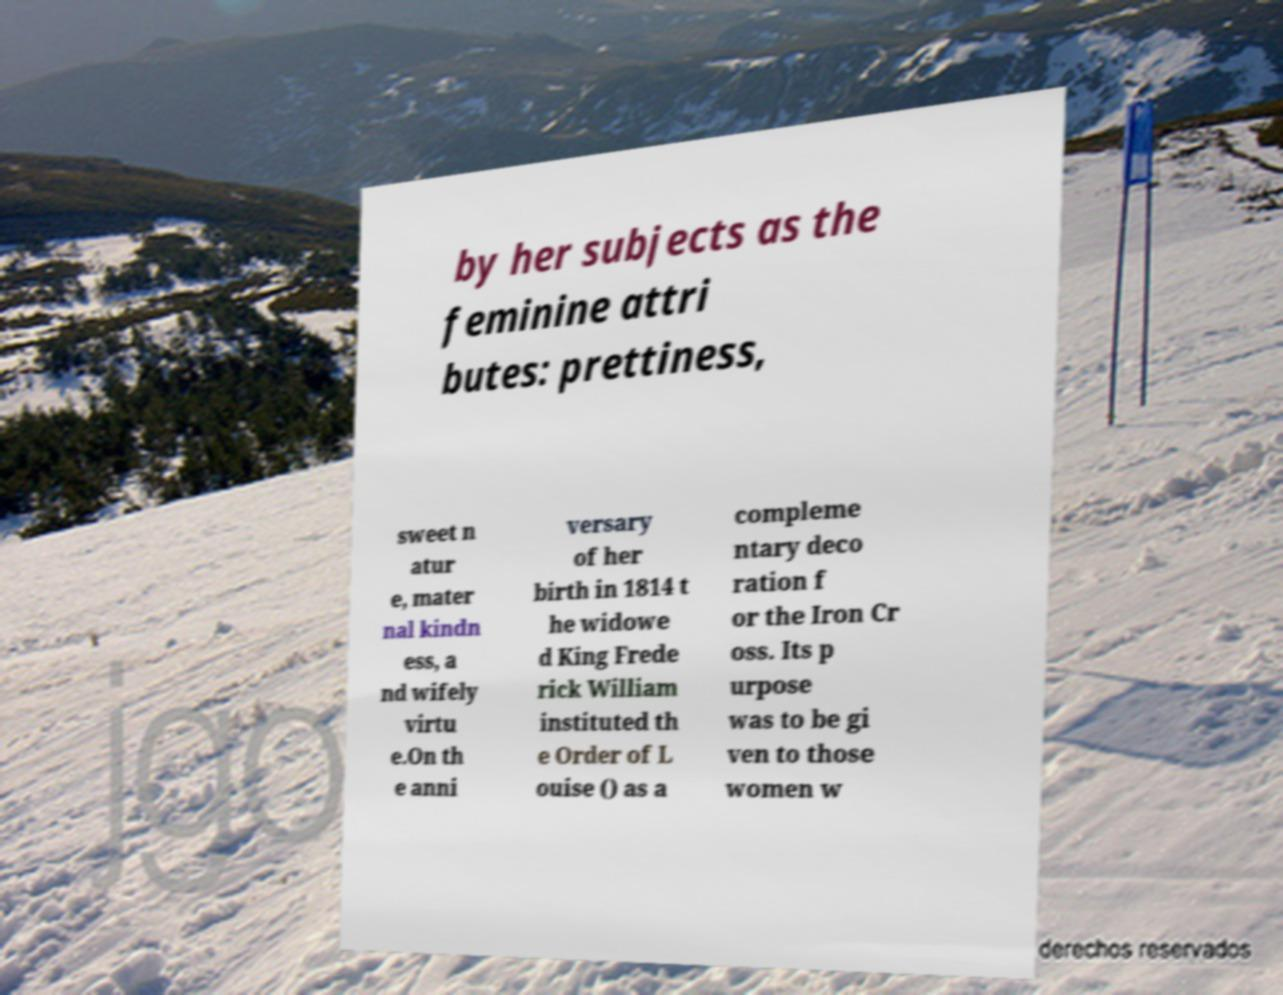Please read and relay the text visible in this image. What does it say? by her subjects as the feminine attri butes: prettiness, sweet n atur e, mater nal kindn ess, a nd wifely virtu e.On th e anni versary of her birth in 1814 t he widowe d King Frede rick William instituted th e Order of L ouise () as a compleme ntary deco ration f or the Iron Cr oss. Its p urpose was to be gi ven to those women w 